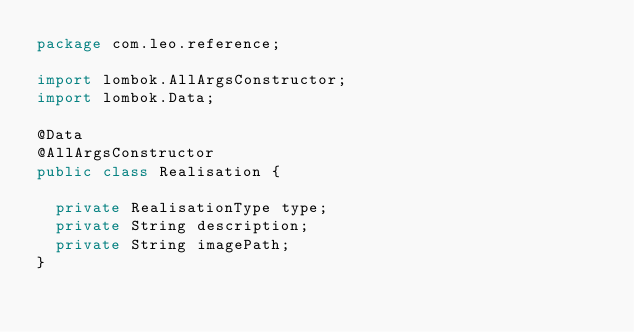<code> <loc_0><loc_0><loc_500><loc_500><_Java_>package com.leo.reference;

import lombok.AllArgsConstructor;
import lombok.Data;

@Data
@AllArgsConstructor
public class Realisation {

	private RealisationType type;
	private String description;
	private String imagePath;
}
</code> 